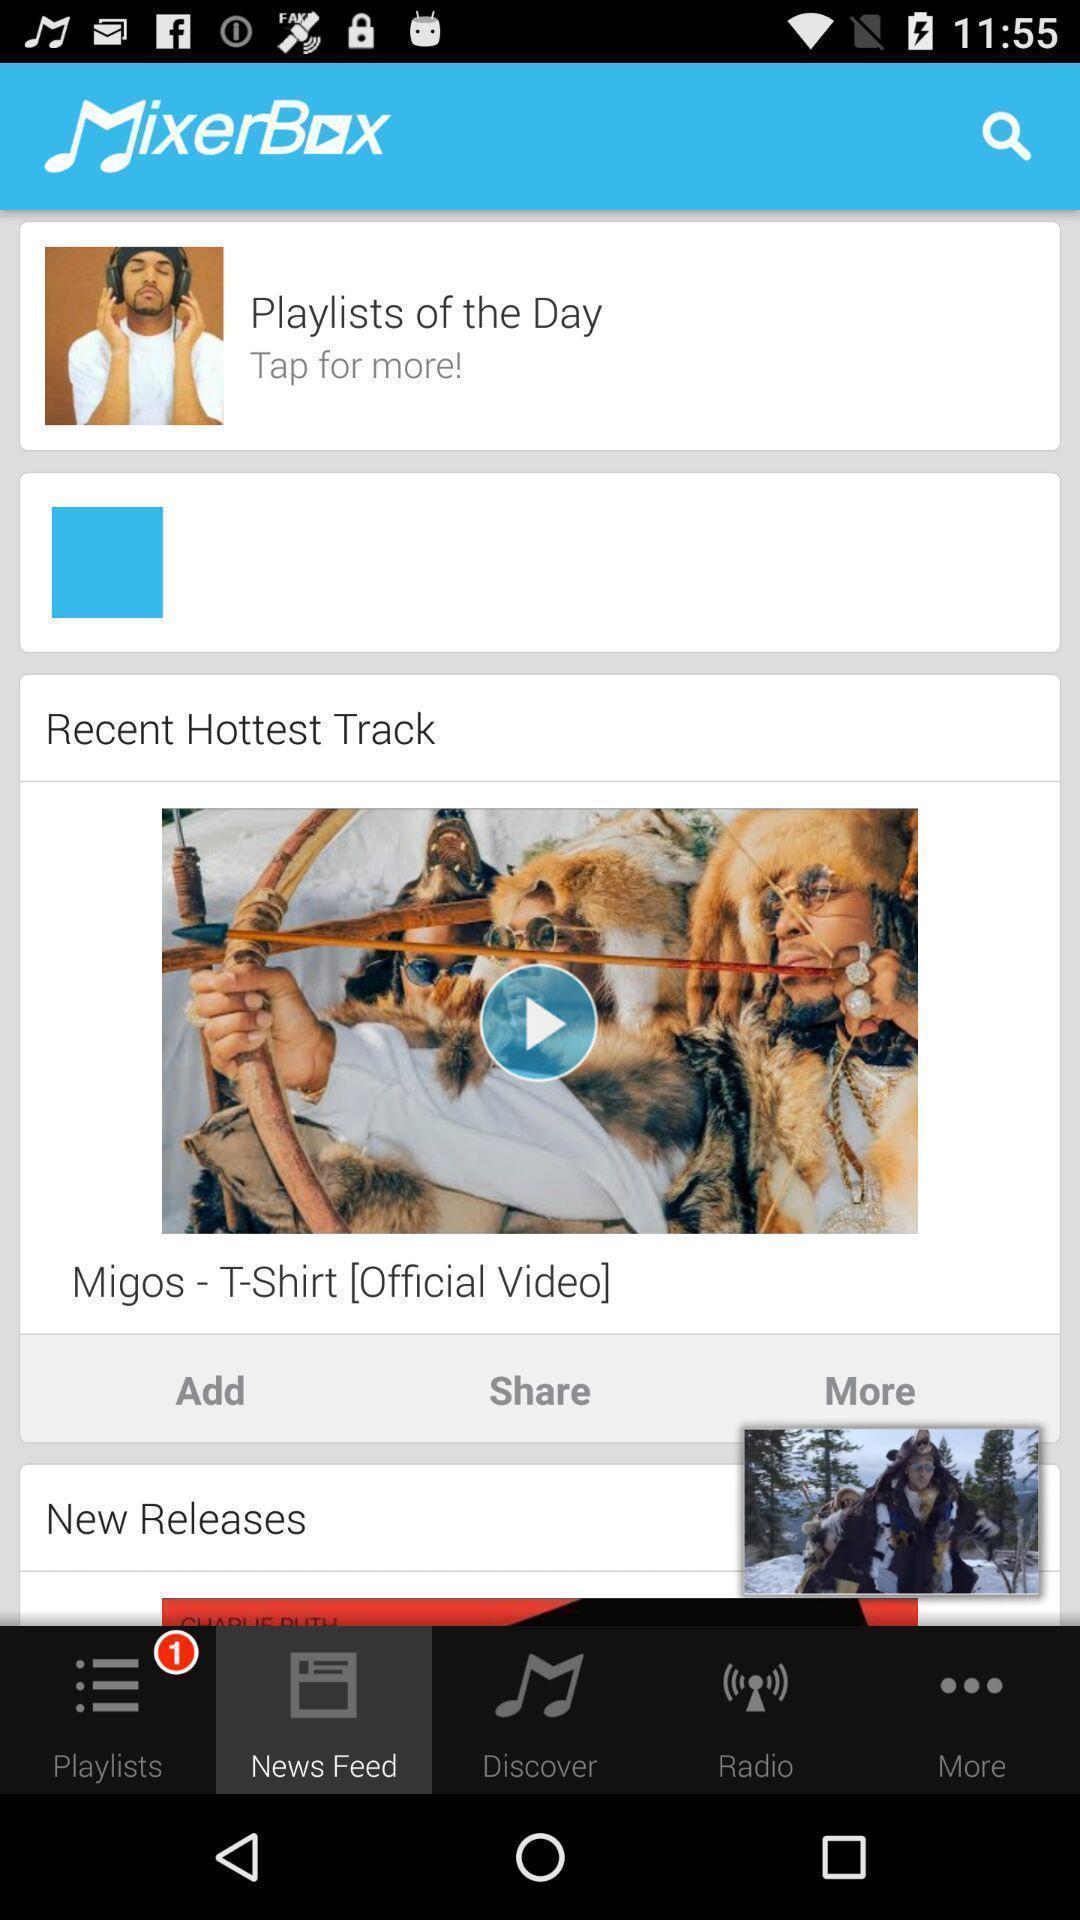What can you discern from this picture? Screen displaying multiple options in a music application. 